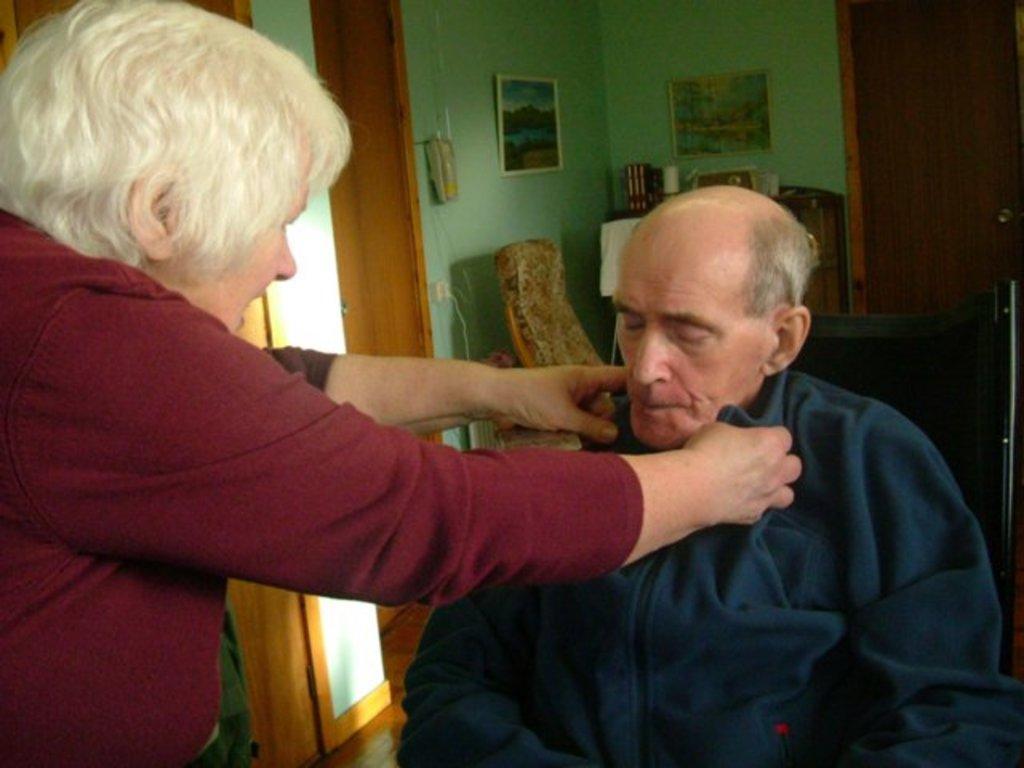Describe this image in one or two sentences. In this image we can see a man and a woman. On the backside we can see a telephone and photo frames on a wall, a door and some chairs. We can also see some books and a bottle on the table. 